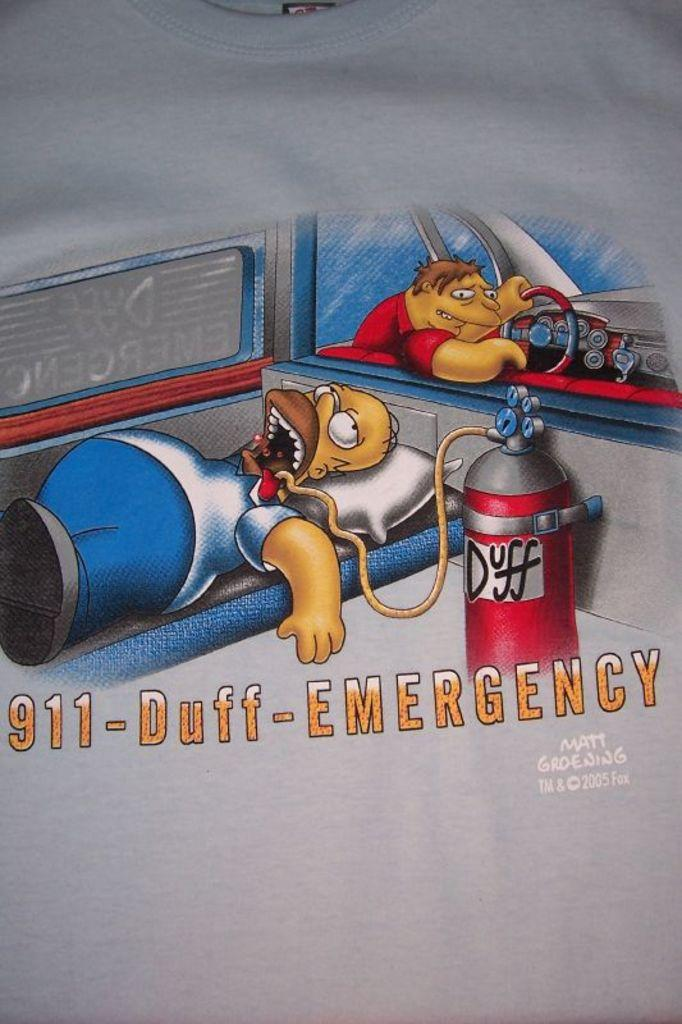Provide a one-sentence caption for the provided image. Homer Simpson lays in an ambulance with a rubber hose in his mouth that is connected to a canister saying Duff. 